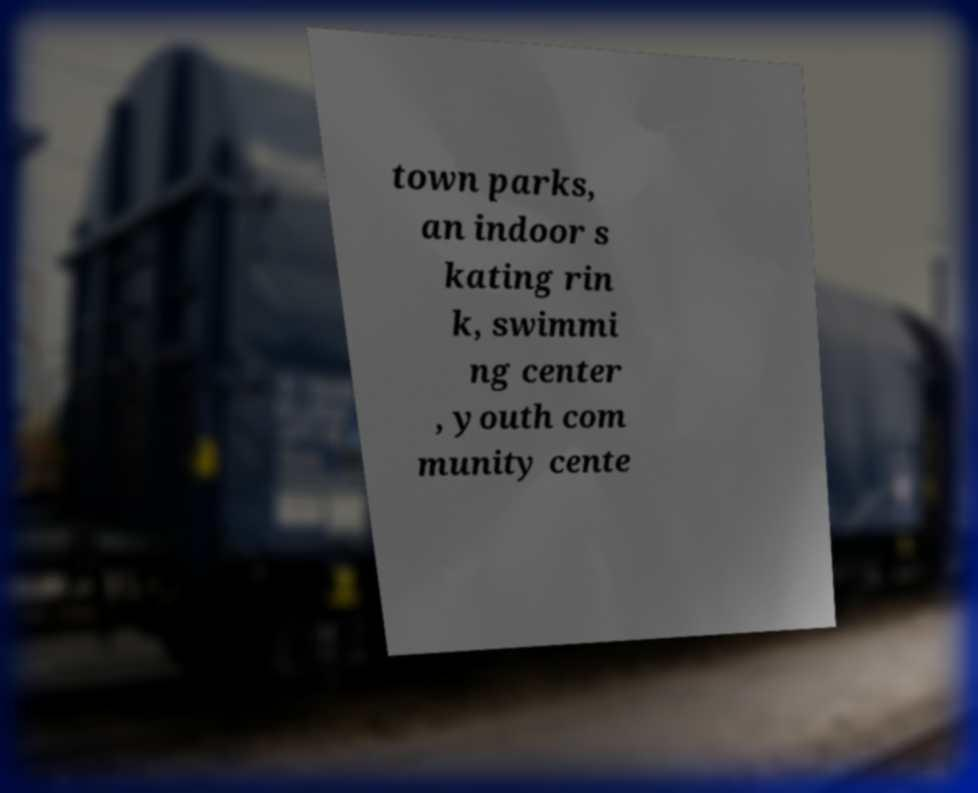Could you extract and type out the text from this image? town parks, an indoor s kating rin k, swimmi ng center , youth com munity cente 